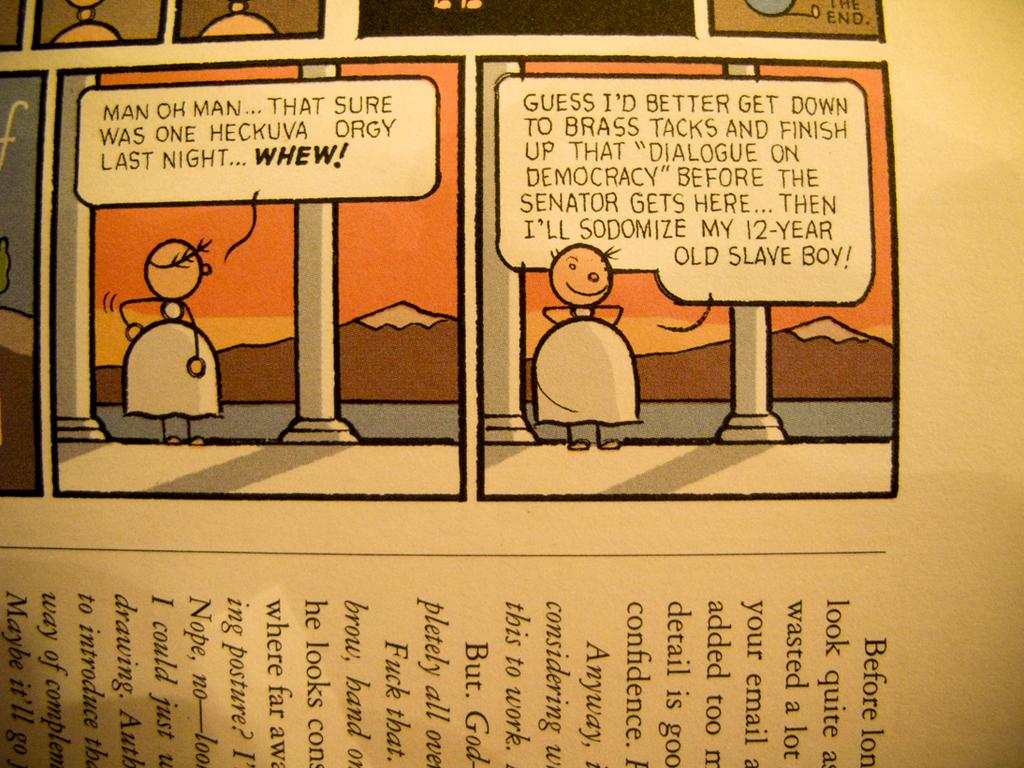What is depicted on the paper in the image? There are pictures and text on a paper in the image. What can be seen in the center of the image? There is a hill and a pillar in the center of the image. What is visible in the background of the image? The sky is visible in the image. How many bells are hanging from the pillar in the image? There are no bells present in the image; it only features a hill and a pillar. What type of form is used to create the hill in the image? The hill in the image is a natural formation and does not involve any specific form or structure. 